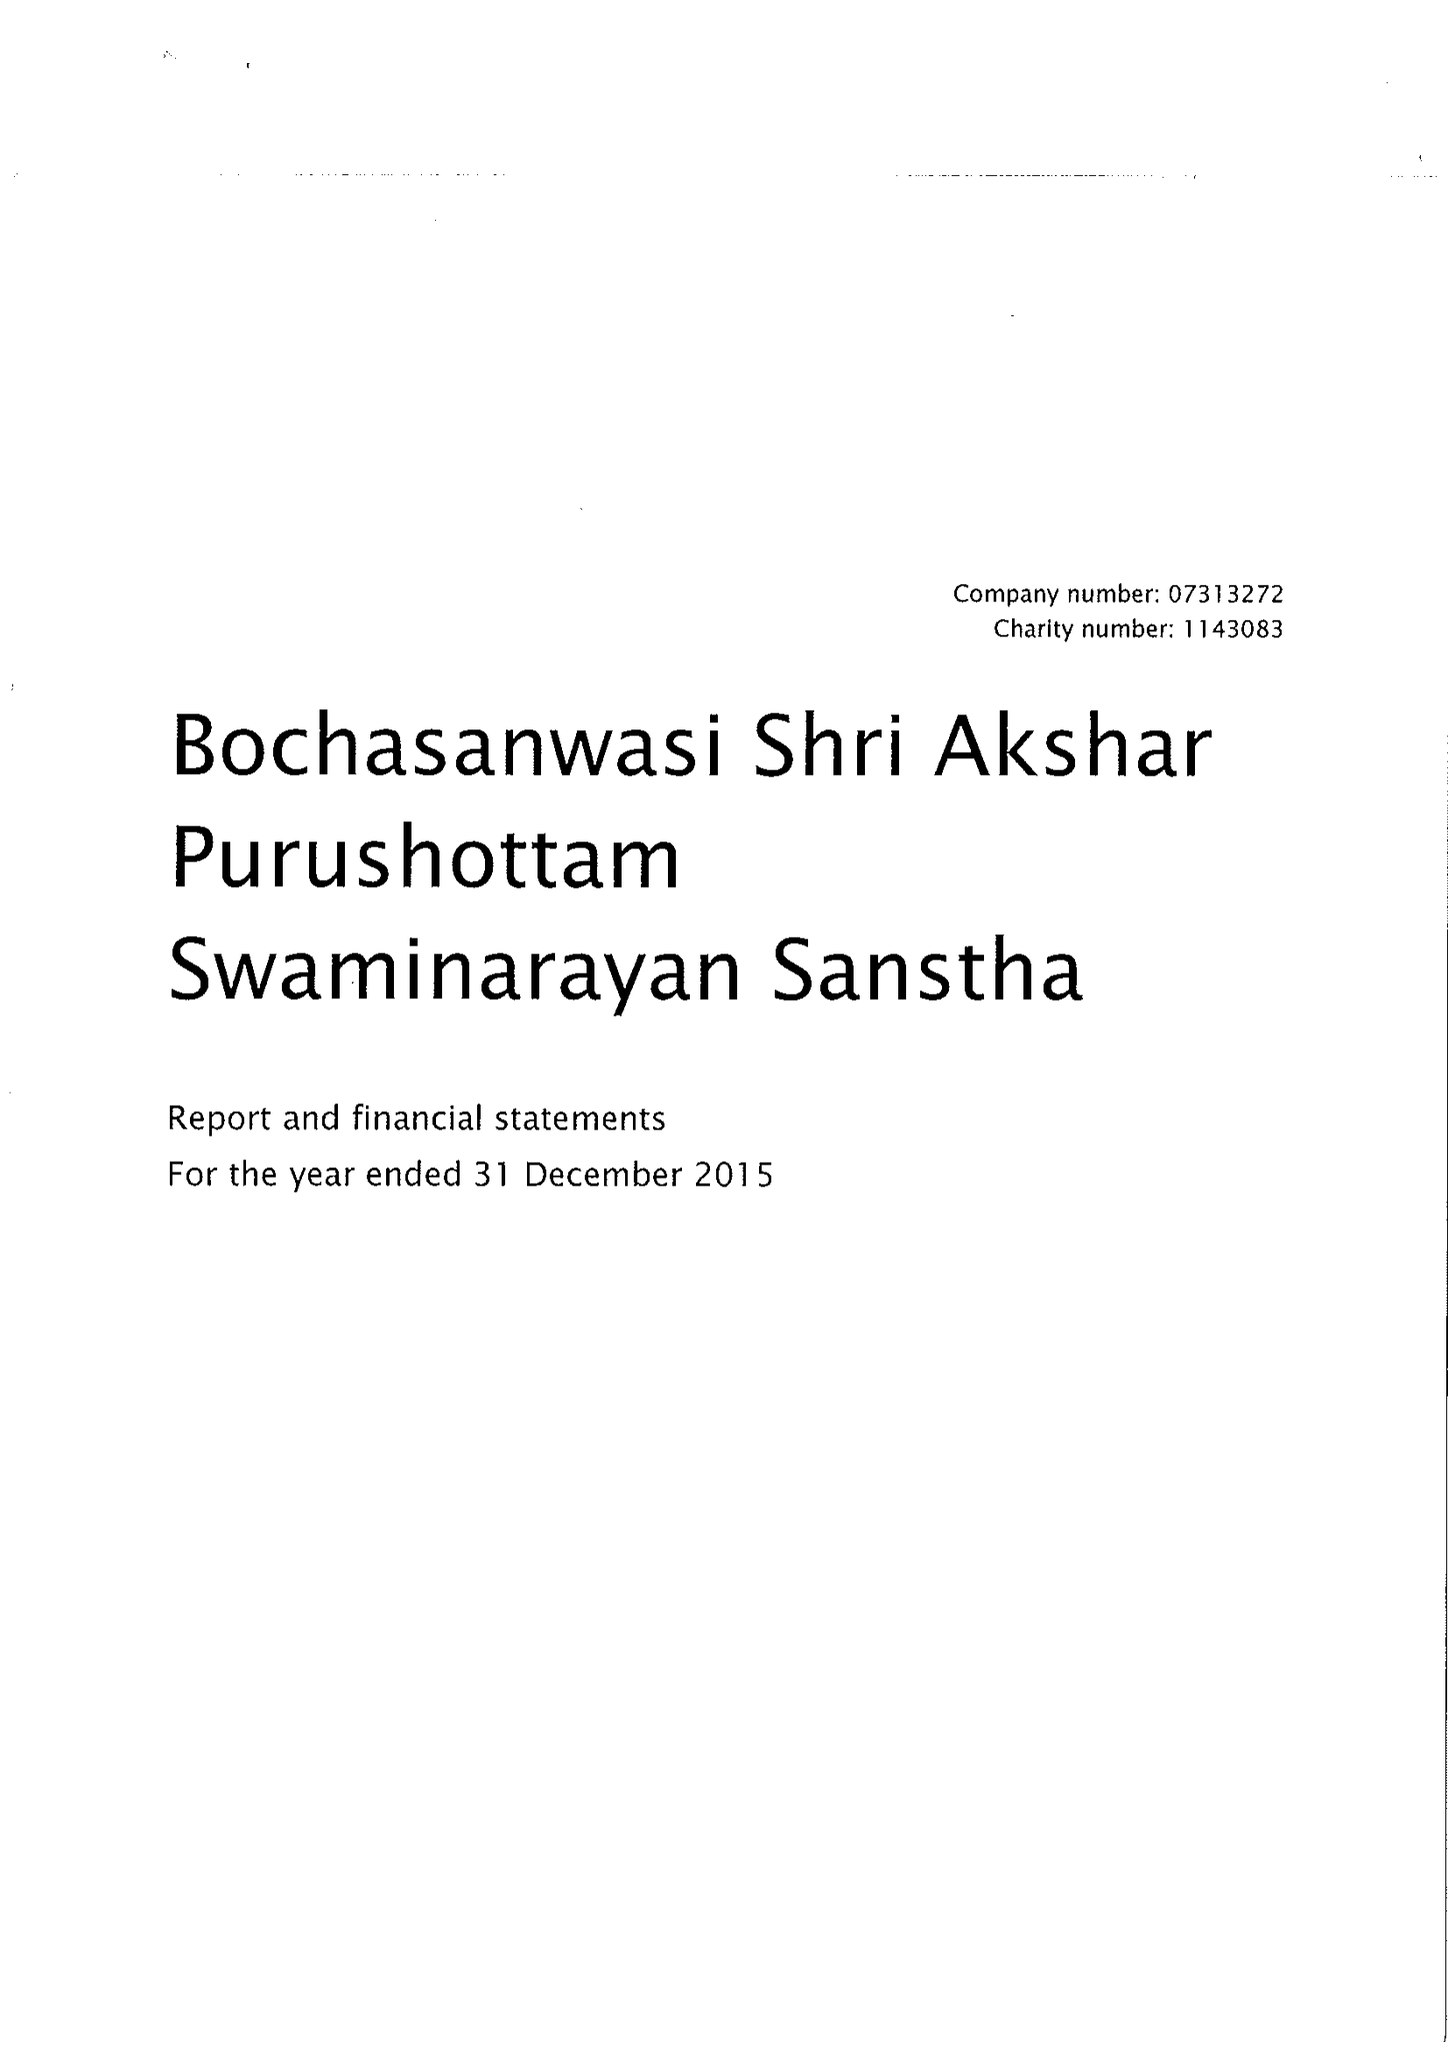What is the value for the address__postcode?
Answer the question using a single word or phrase. NW10 8LD 